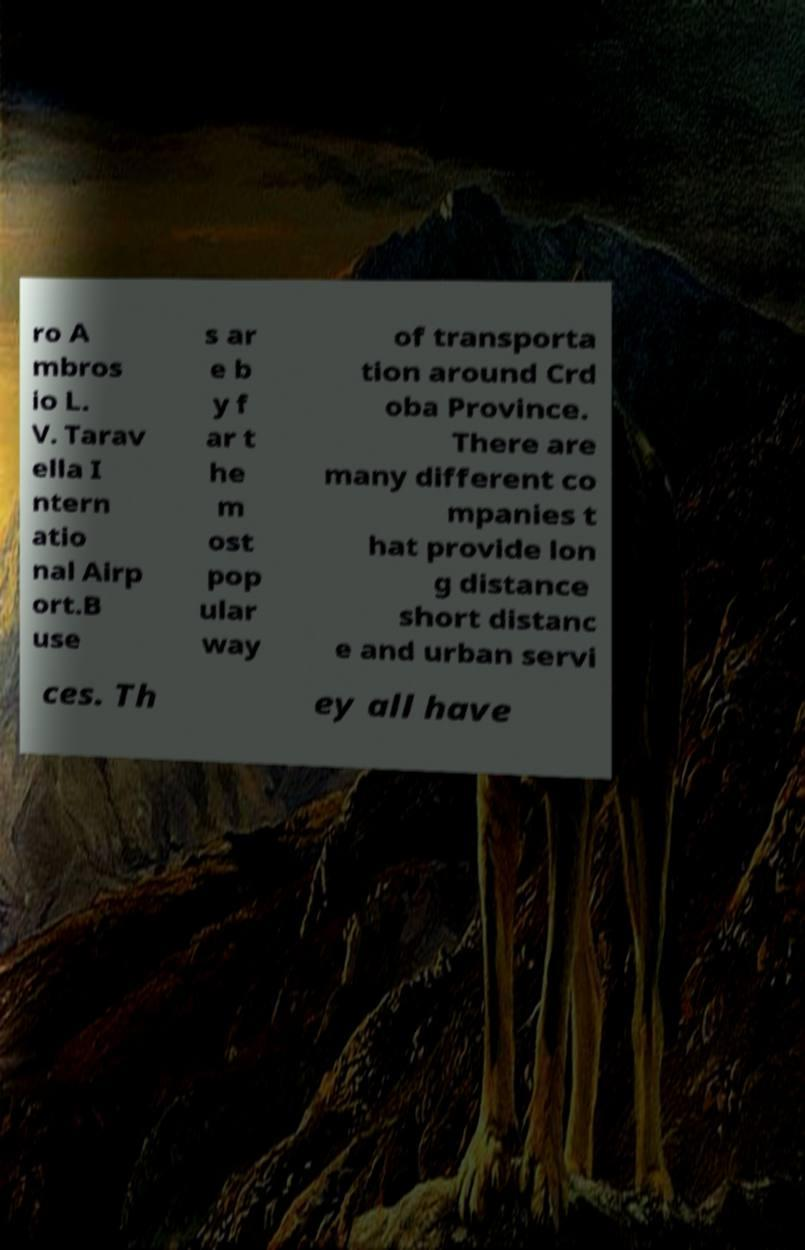There's text embedded in this image that I need extracted. Can you transcribe it verbatim? ro A mbros io L. V. Tarav ella I ntern atio nal Airp ort.B use s ar e b y f ar t he m ost pop ular way of transporta tion around Crd oba Province. There are many different co mpanies t hat provide lon g distance short distanc e and urban servi ces. Th ey all have 